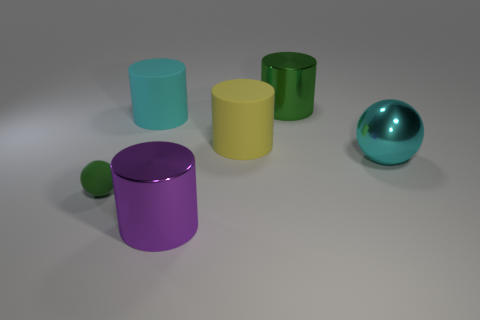There is a metal object that is the same color as the tiny matte ball; what is its size?
Your answer should be very brief. Large. What size is the shiny object that is the same shape as the small matte object?
Offer a very short reply. Large. Are there any other things that are made of the same material as the big purple cylinder?
Provide a short and direct response. Yes. Do the shiny ball right of the small green rubber thing and the cyan object behind the yellow matte object have the same size?
Your response must be concise. Yes. How many small things are green metal things or yellow rubber cylinders?
Offer a terse response. 0. How many large metallic objects are to the left of the green metallic thing and behind the tiny green matte object?
Your answer should be compact. 0. Are there an equal number of large objects and yellow cylinders?
Offer a terse response. No. Does the big cyan ball have the same material as the big cylinder on the right side of the yellow rubber thing?
Give a very brief answer. Yes. What number of cyan things are big metallic balls or shiny cylinders?
Give a very brief answer. 1. Is there a green rubber object of the same size as the cyan shiny object?
Give a very brief answer. No. 